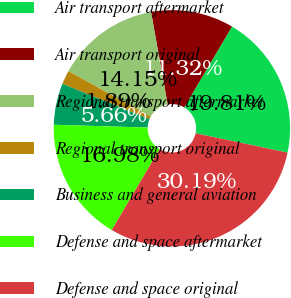<chart> <loc_0><loc_0><loc_500><loc_500><pie_chart><fcel>Air transport aftermarket<fcel>Air transport original<fcel>Regional transport aftermarket<fcel>Regional transport original<fcel>Business and general aviation<fcel>Defense and space aftermarket<fcel>Defense and space original<nl><fcel>19.81%<fcel>11.32%<fcel>14.15%<fcel>1.89%<fcel>5.66%<fcel>16.98%<fcel>30.19%<nl></chart> 